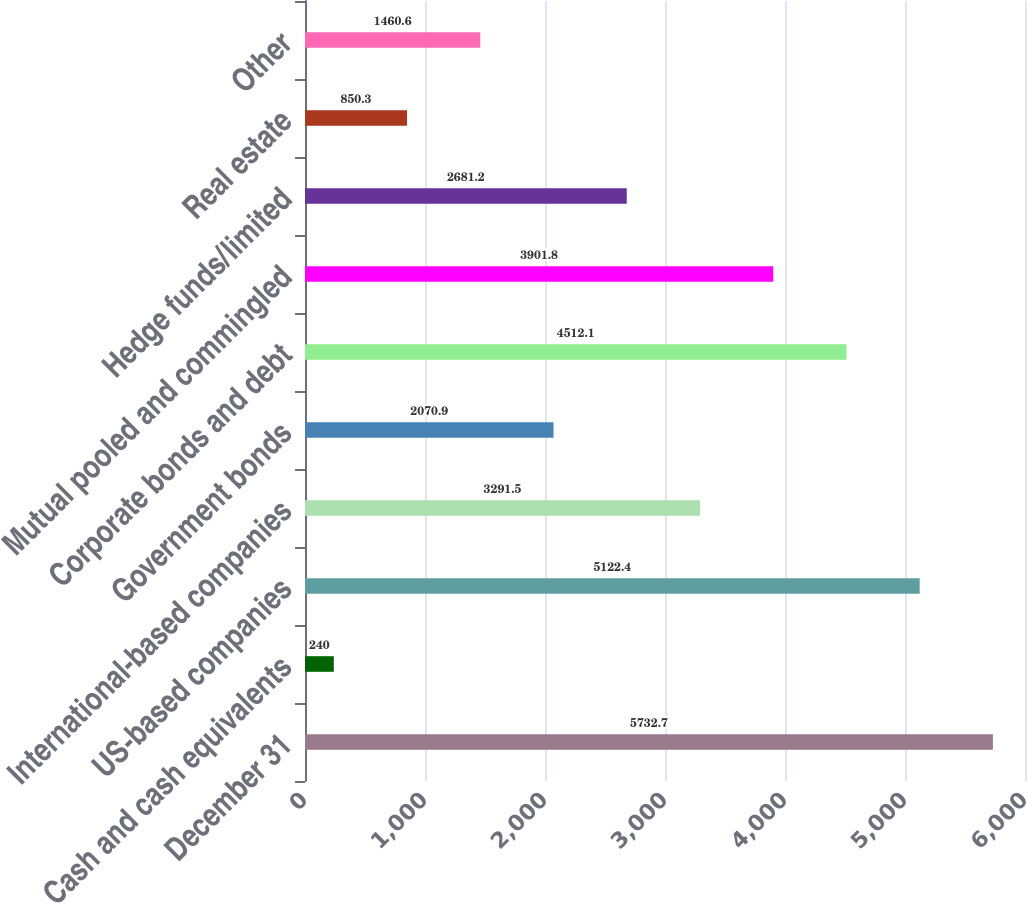Convert chart. <chart><loc_0><loc_0><loc_500><loc_500><bar_chart><fcel>December 31<fcel>Cash and cash equivalents<fcel>US-based companies<fcel>International-based companies<fcel>Government bonds<fcel>Corporate bonds and debt<fcel>Mutual pooled and commingled<fcel>Hedge funds/limited<fcel>Real estate<fcel>Other<nl><fcel>5732.7<fcel>240<fcel>5122.4<fcel>3291.5<fcel>2070.9<fcel>4512.1<fcel>3901.8<fcel>2681.2<fcel>850.3<fcel>1460.6<nl></chart> 